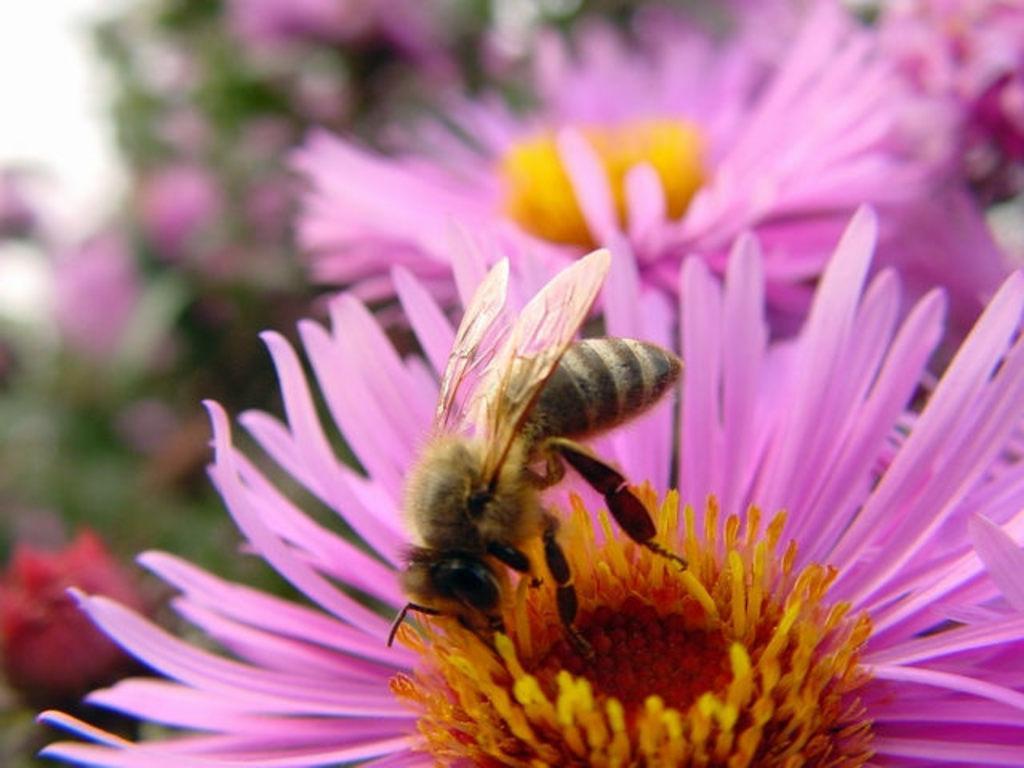Can you describe this image briefly? In the center of the image there is a flowers. On flower a honey bee is there. On the left side, the image is blur. 